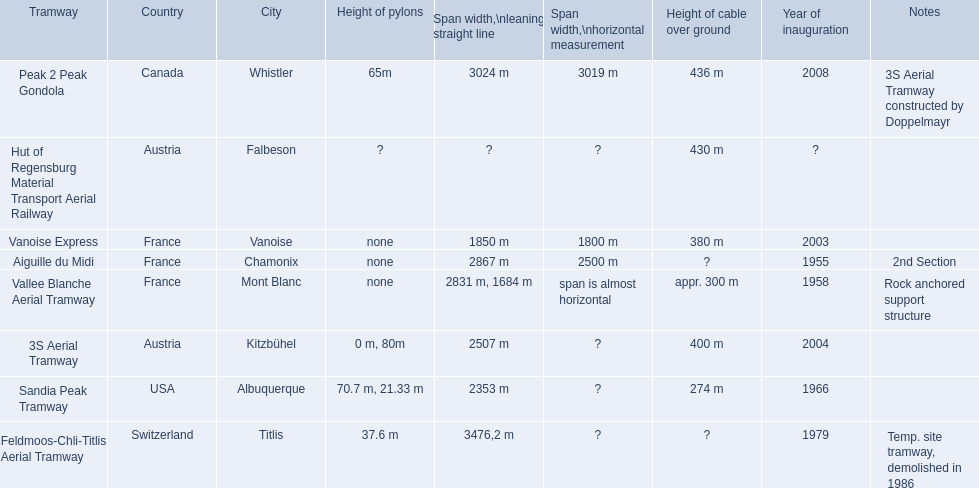Can you list the tramways found in france? Vanoise Express, Aiguille du Midi, Vallee Blanche Aerial Tramway. Among them, which were inaugurated during the 1950s? Aiguille du Midi, Vallee Blanche Aerial Tramway. Are there any that have spans not close to being horizontal? Aiguille du Midi. Parse the full table in json format. {'header': ['Tramway', 'Country', 'City', 'Height of pylons', 'Span\xa0width,\\nleaning straight line', 'Span width,\\nhorizontal measurement', 'Height of cable over ground', 'Year of inauguration', 'Notes'], 'rows': [['Peak 2 Peak Gondola', 'Canada', 'Whistler', '65m', '3024 m', '3019 m', '436 m', '2008', '3S Aerial Tramway constructed by Doppelmayr'], ['Hut of Regensburg Material Transport Aerial Railway', 'Austria', 'Falbeson', '?', '?', '?', '430 m', '?', ''], ['Vanoise Express', 'France', 'Vanoise', 'none', '1850 m', '1800 m', '380 m', '2003', ''], ['Aiguille du Midi', 'France', 'Chamonix', 'none', '2867 m', '2500 m', '?', '1955', '2nd Section'], ['Vallee Blanche Aerial Tramway', 'France', 'Mont Blanc', 'none', '2831 m, 1684 m', 'span is almost horizontal', 'appr. 300 m', '1958', 'Rock anchored support structure'], ['3S Aerial Tramway', 'Austria', 'Kitzbühel', '0 m, 80m', '2507 m', '?', '400 m', '2004', ''], ['Sandia Peak Tramway', 'USA', 'Albuquerque', '70.7 m, 21.33 m', '2353 m', '?', '274 m', '1966', ''], ['Feldmoos-Chli-Titlis Aerial Tramway', 'Switzerland', 'Titlis', '37.6 m', '3476,2 m', '?', '?', '1979', 'Temp. site tramway, demolished in 1986']]} 